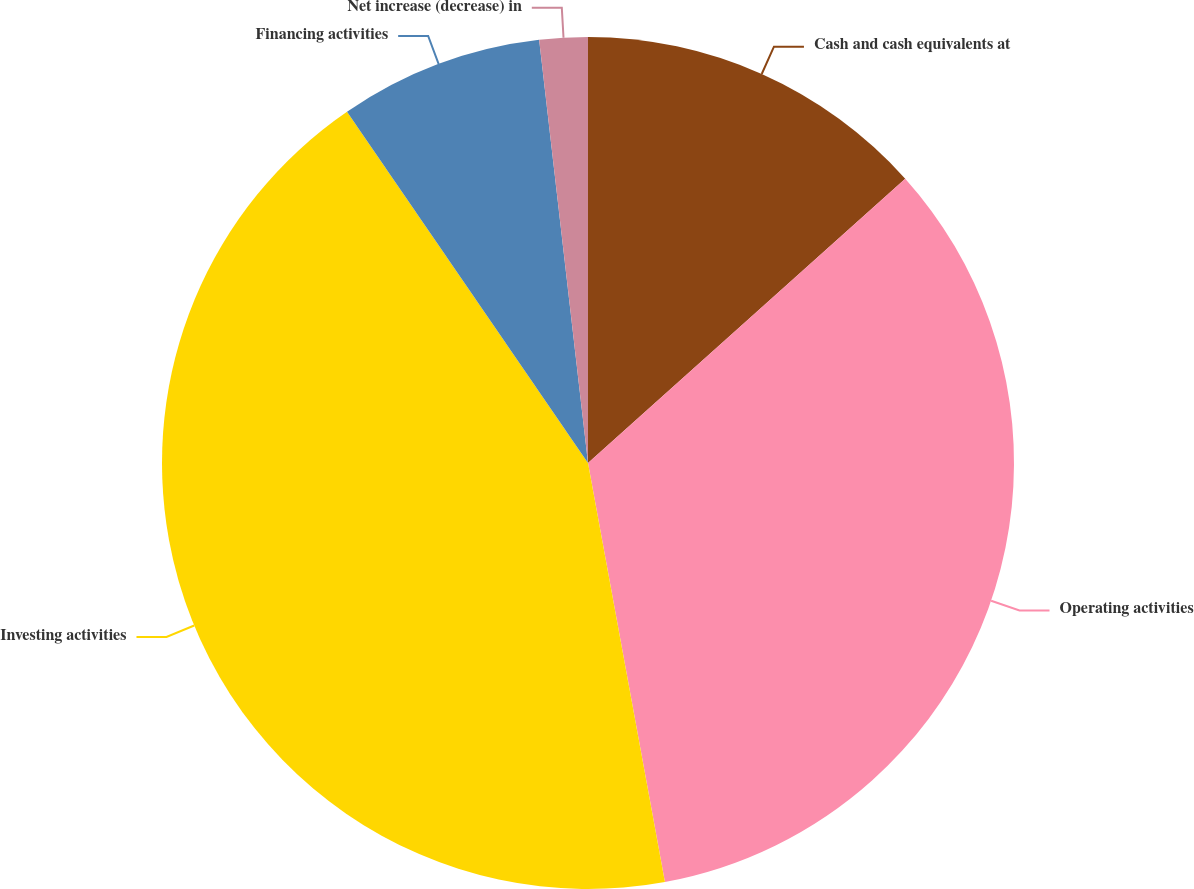Convert chart to OTSL. <chart><loc_0><loc_0><loc_500><loc_500><pie_chart><fcel>Cash and cash equivalents at<fcel>Operating activities<fcel>Investing activities<fcel>Financing activities<fcel>Net increase (decrease) in<nl><fcel>13.37%<fcel>33.74%<fcel>43.32%<fcel>7.74%<fcel>1.83%<nl></chart> 